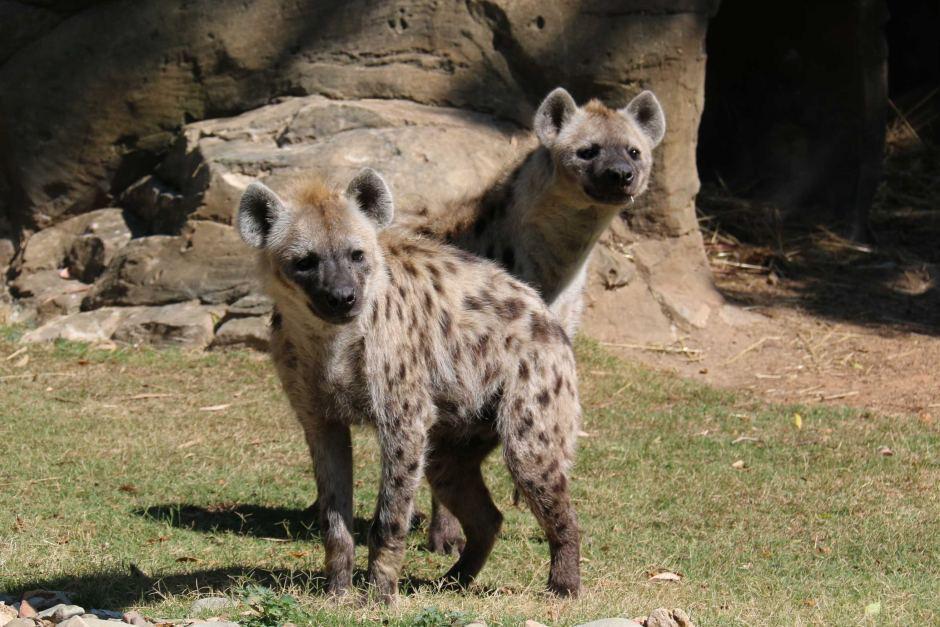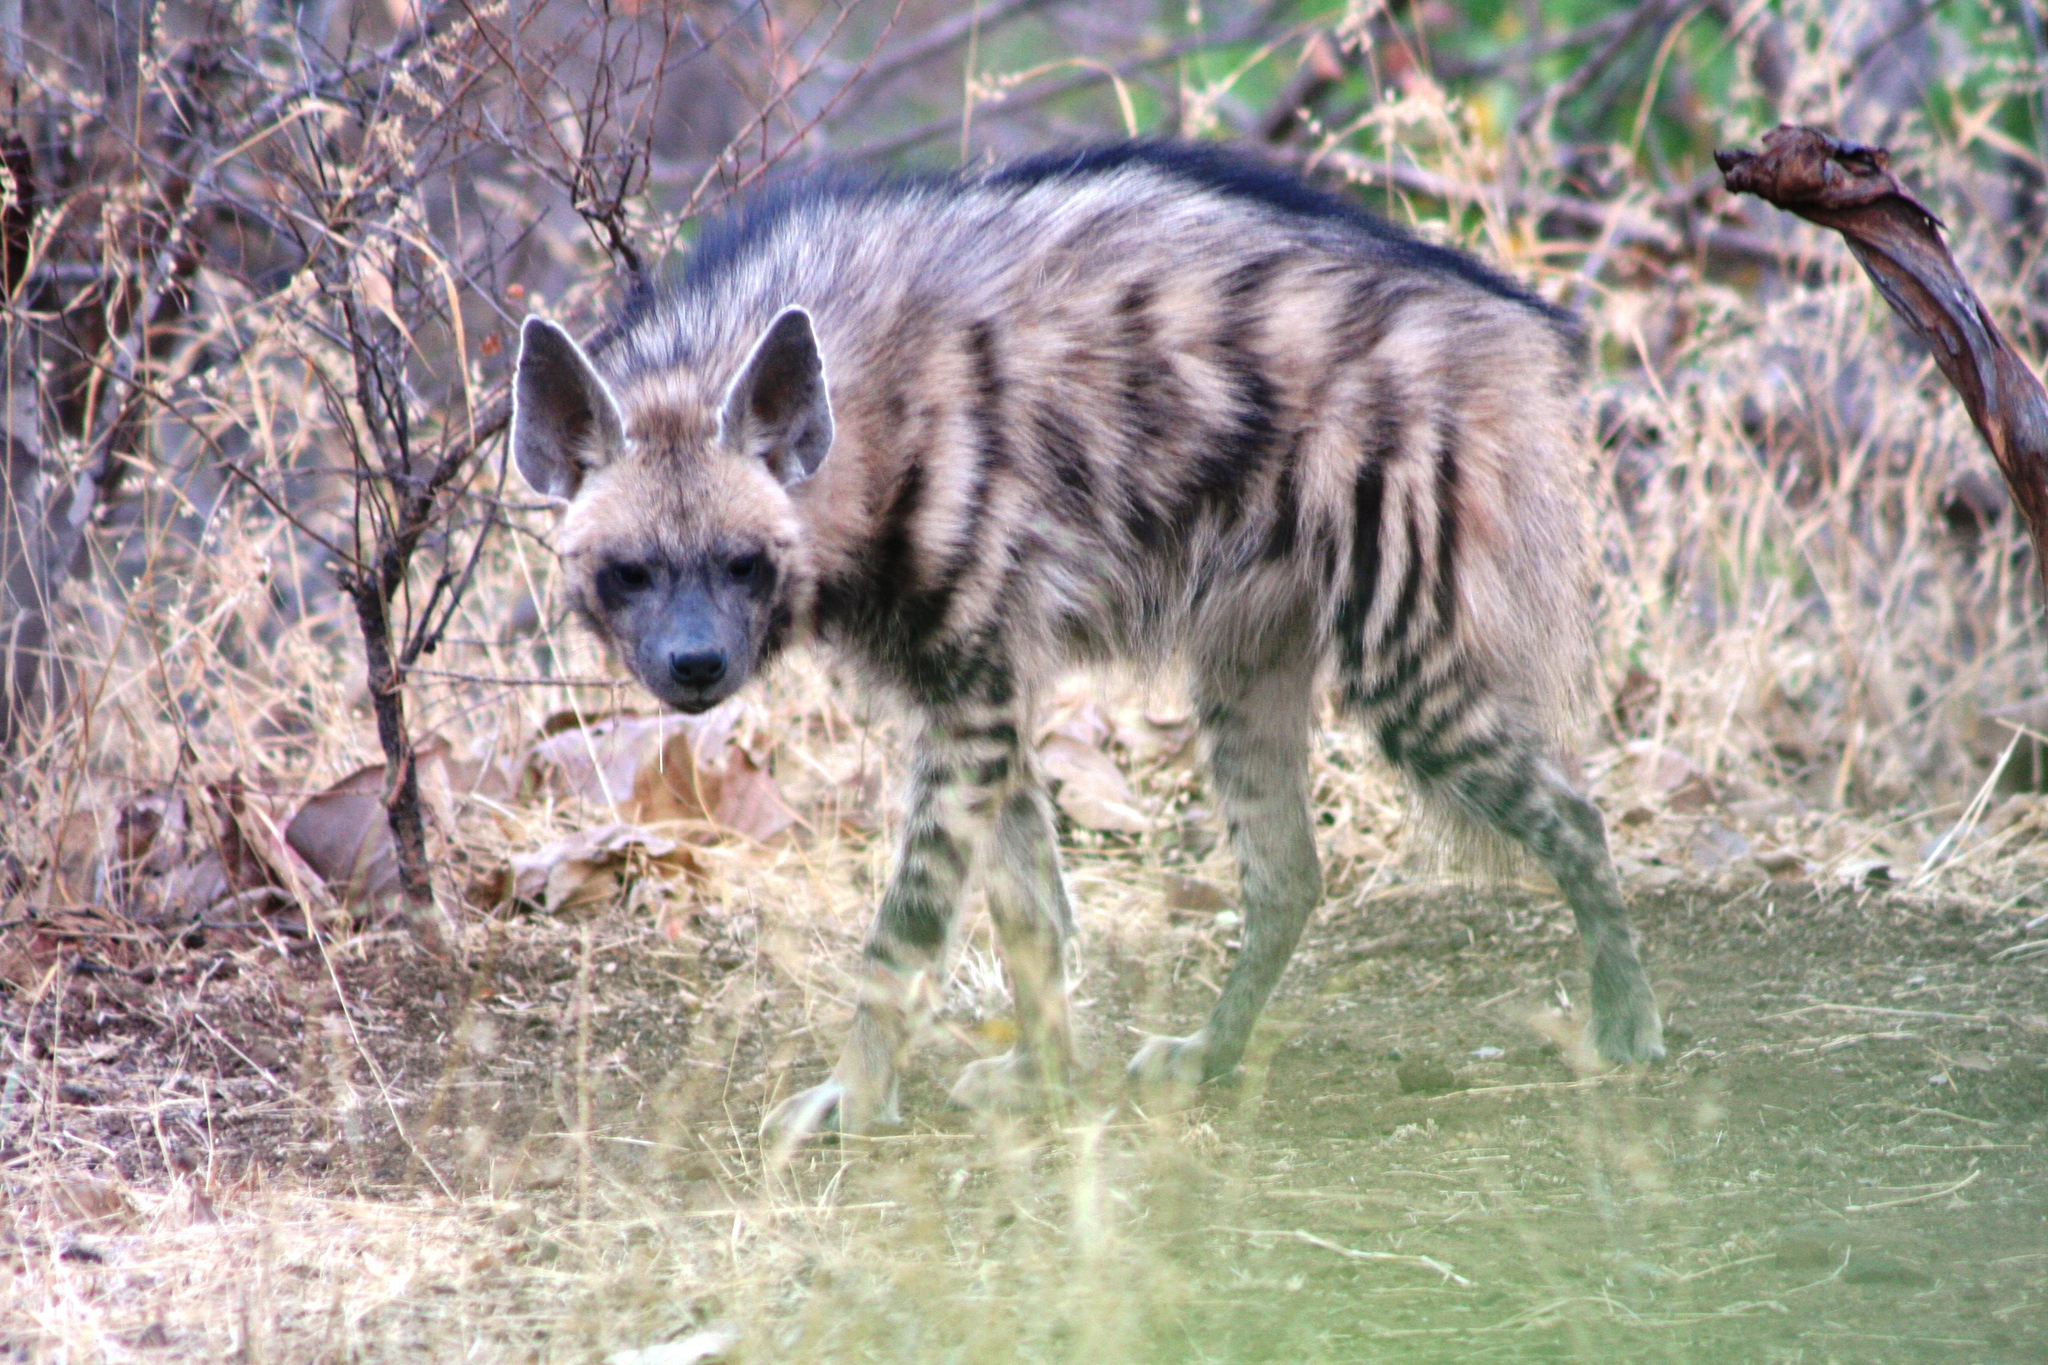The first image is the image on the left, the second image is the image on the right. Given the left and right images, does the statement "none of the hyenas are eating, at the moment." hold true? Answer yes or no. Yes. 